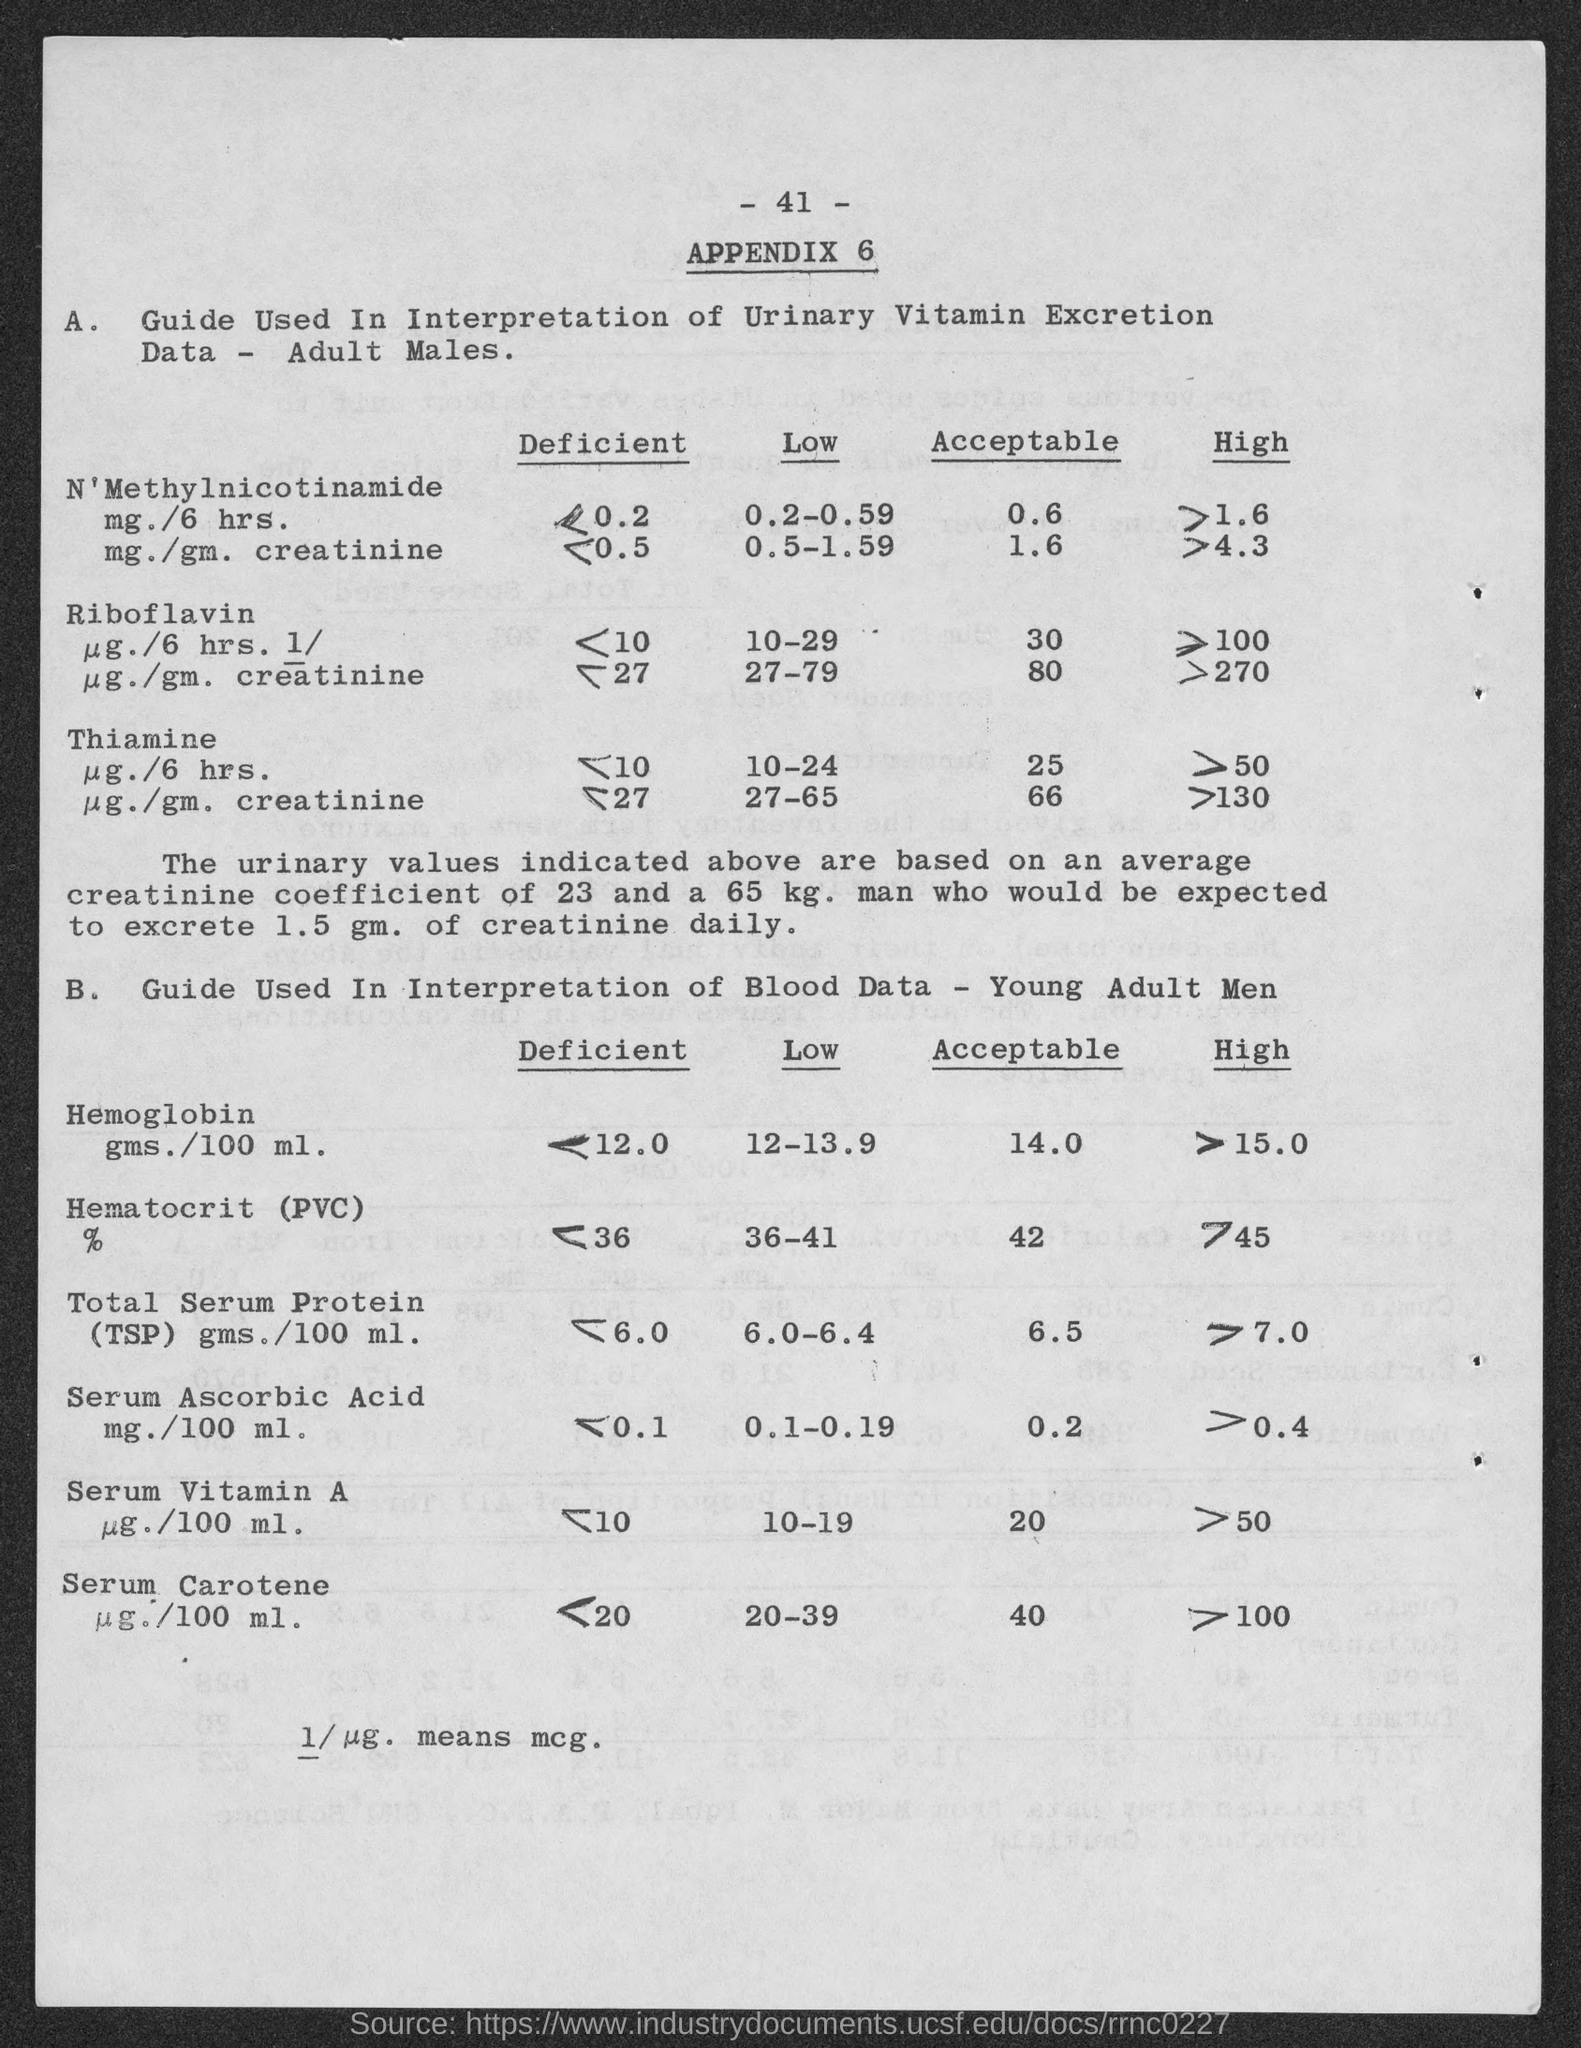Identify some key points in this picture. 1/ug is equivalent to mcg and represents a unit of measurement for the concentration of a substance in a given volume. The low range of serum ascorbic acid is 0.1 to 0.19. The acceptable range of hemoglobin for young adult men is 14.0 to... 